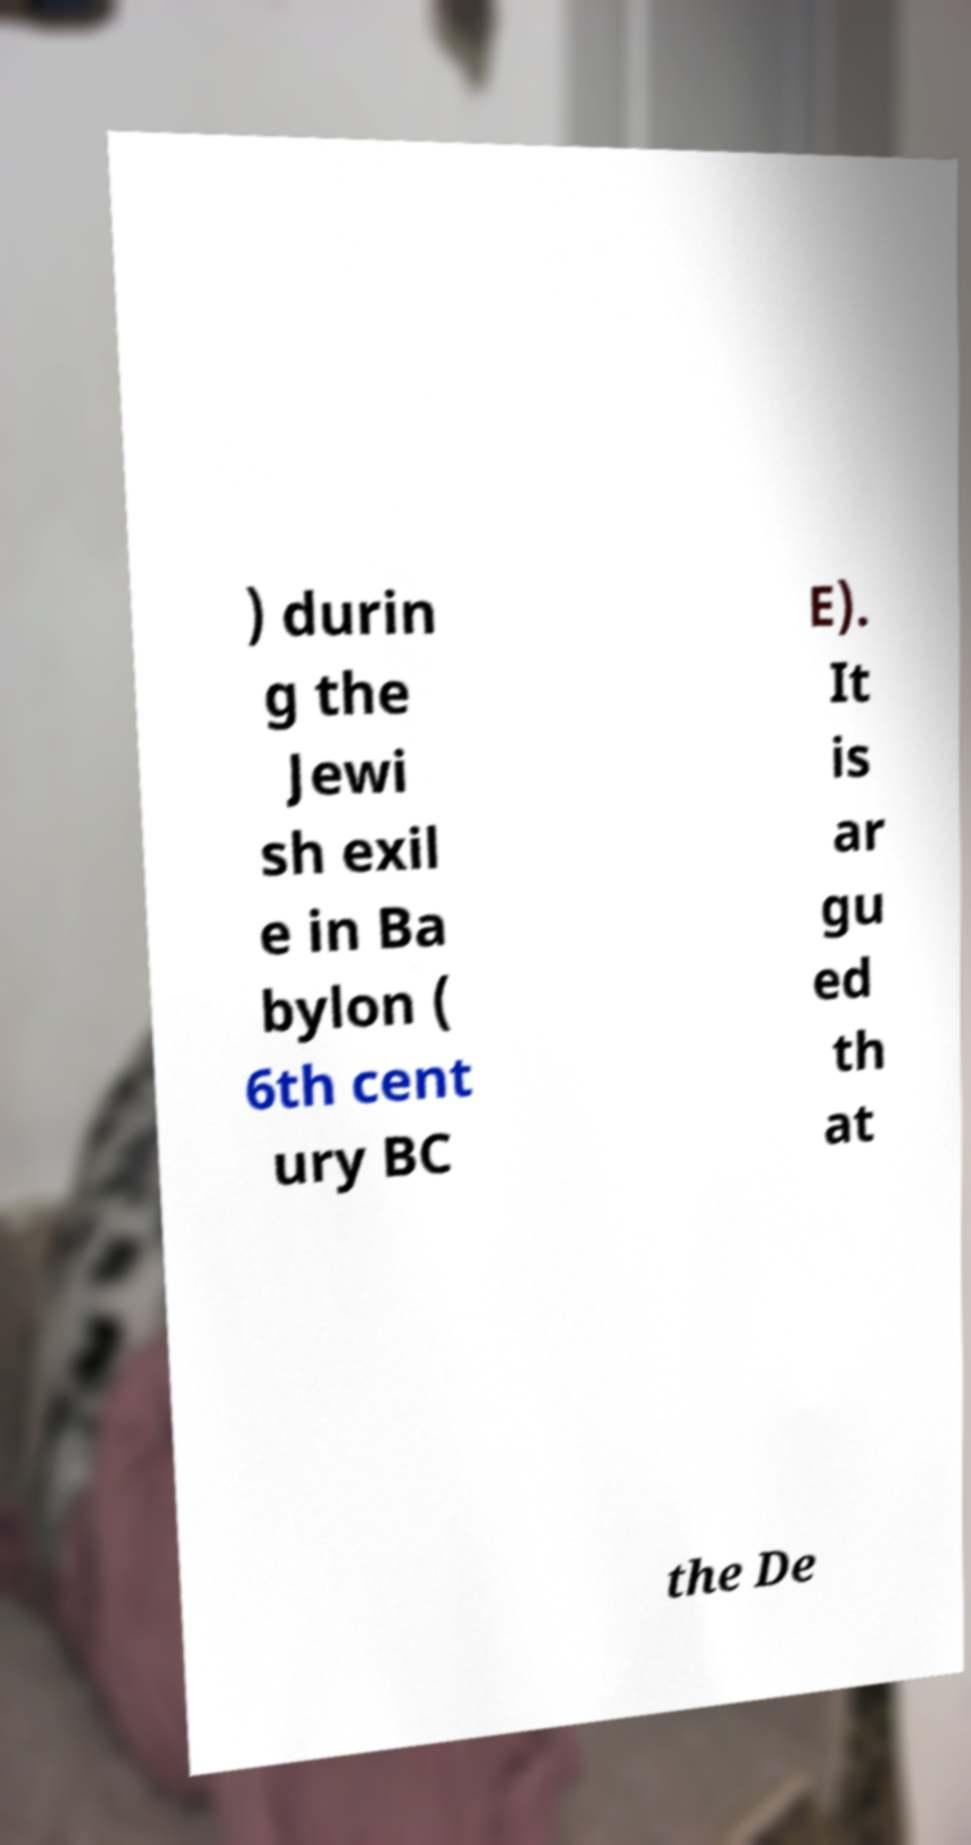Could you assist in decoding the text presented in this image and type it out clearly? ) durin g the Jewi sh exil e in Ba bylon ( 6th cent ury BC E). It is ar gu ed th at the De 